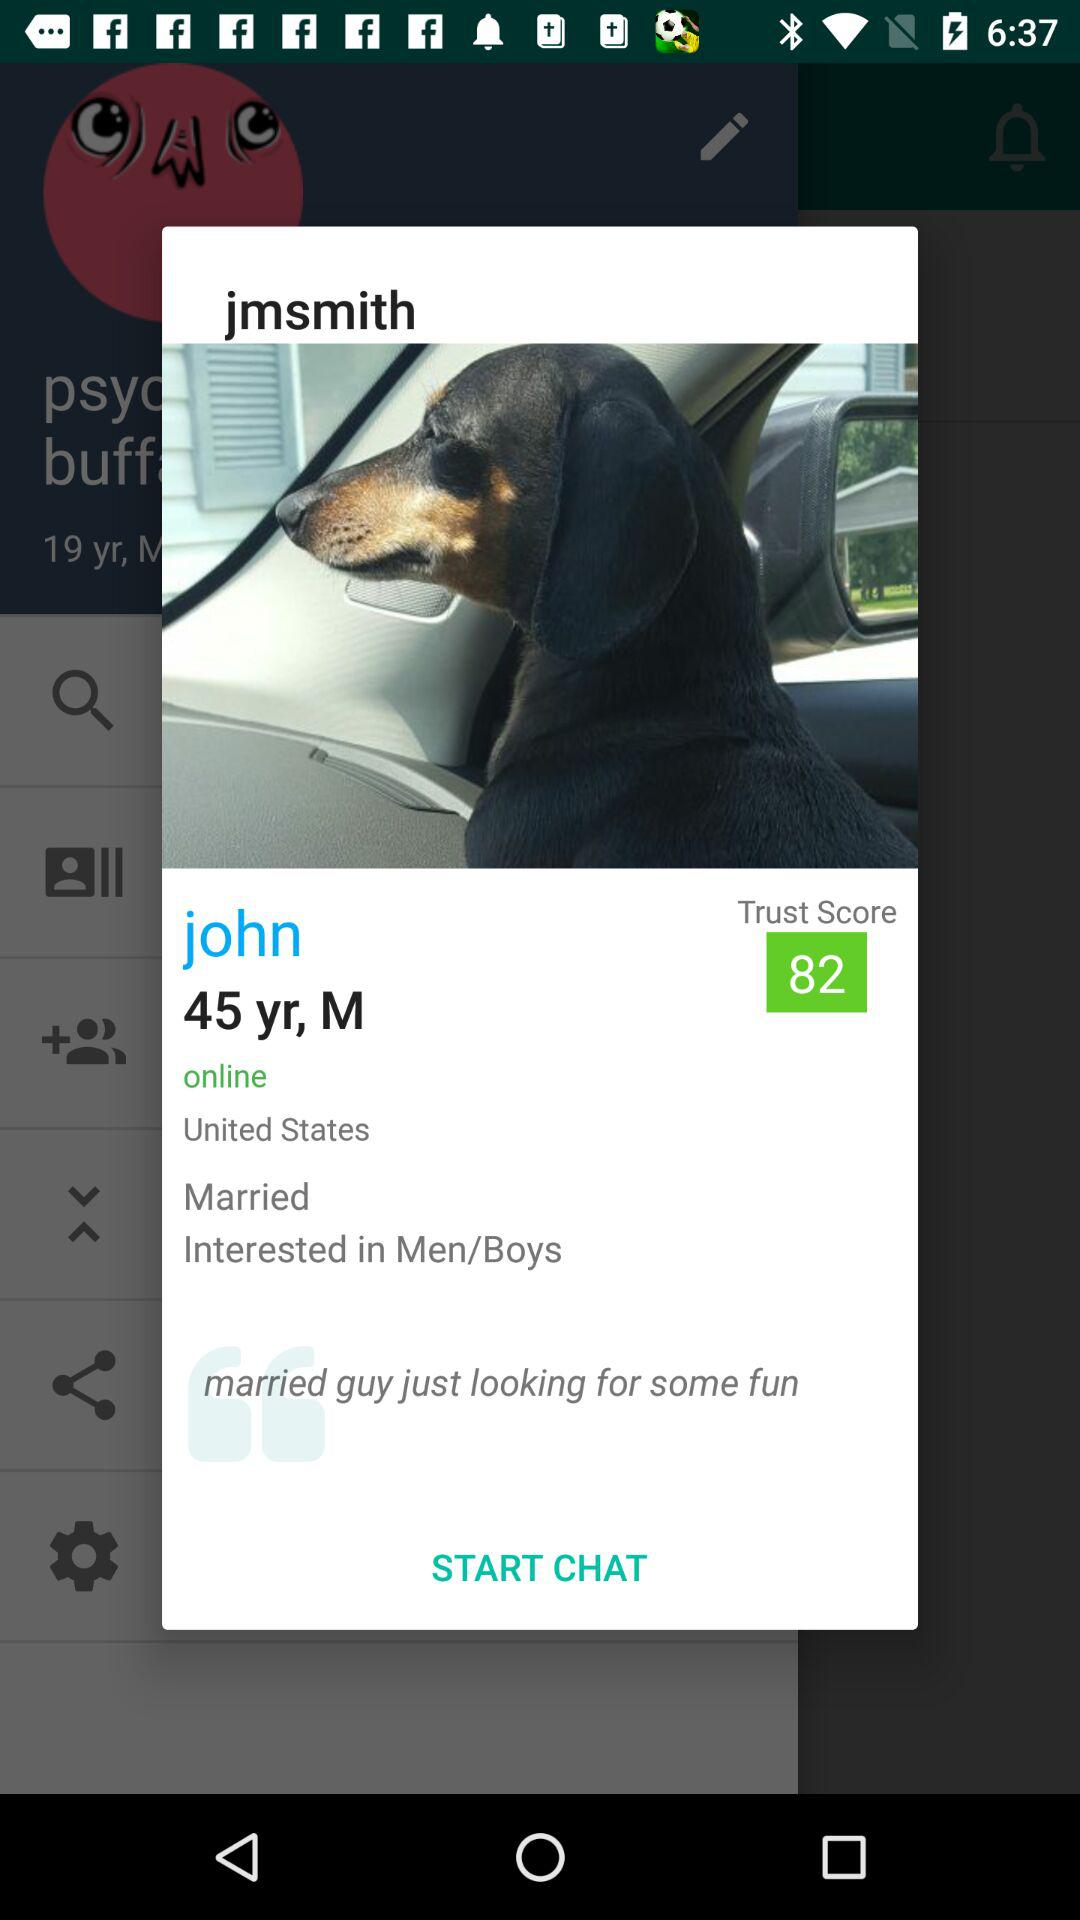What is John's marital status? John's marital status is "Married". 